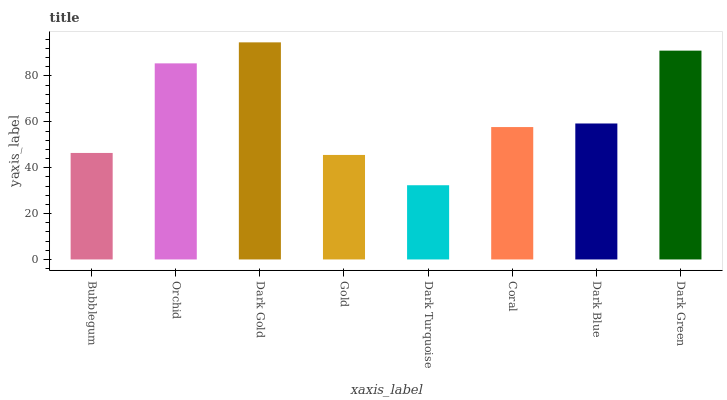Is Orchid the minimum?
Answer yes or no. No. Is Orchid the maximum?
Answer yes or no. No. Is Orchid greater than Bubblegum?
Answer yes or no. Yes. Is Bubblegum less than Orchid?
Answer yes or no. Yes. Is Bubblegum greater than Orchid?
Answer yes or no. No. Is Orchid less than Bubblegum?
Answer yes or no. No. Is Dark Blue the high median?
Answer yes or no. Yes. Is Coral the low median?
Answer yes or no. Yes. Is Bubblegum the high median?
Answer yes or no. No. Is Dark Blue the low median?
Answer yes or no. No. 